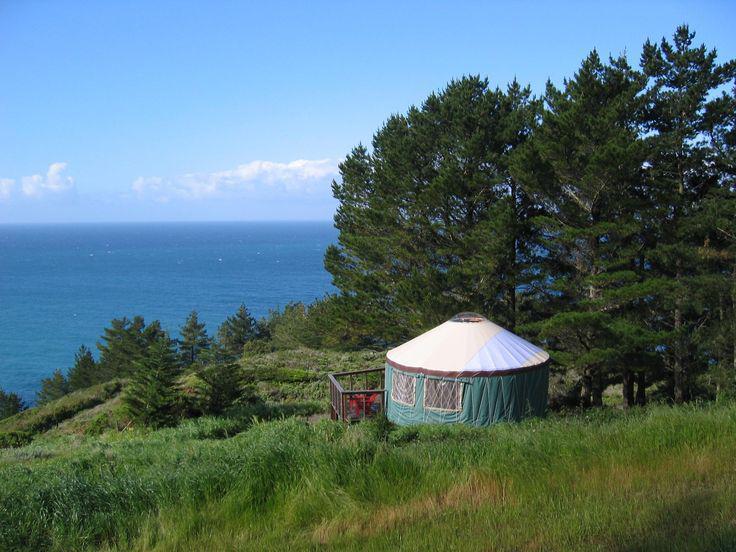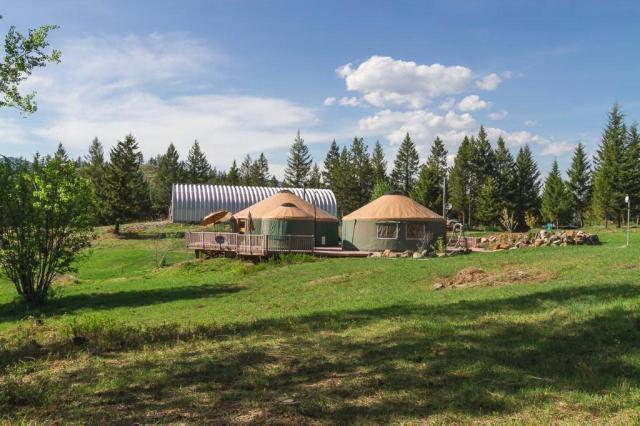The first image is the image on the left, the second image is the image on the right. Analyze the images presented: Is the assertion "An image includes at least four cone-topped tents in a row." valid? Answer yes or no. No. 